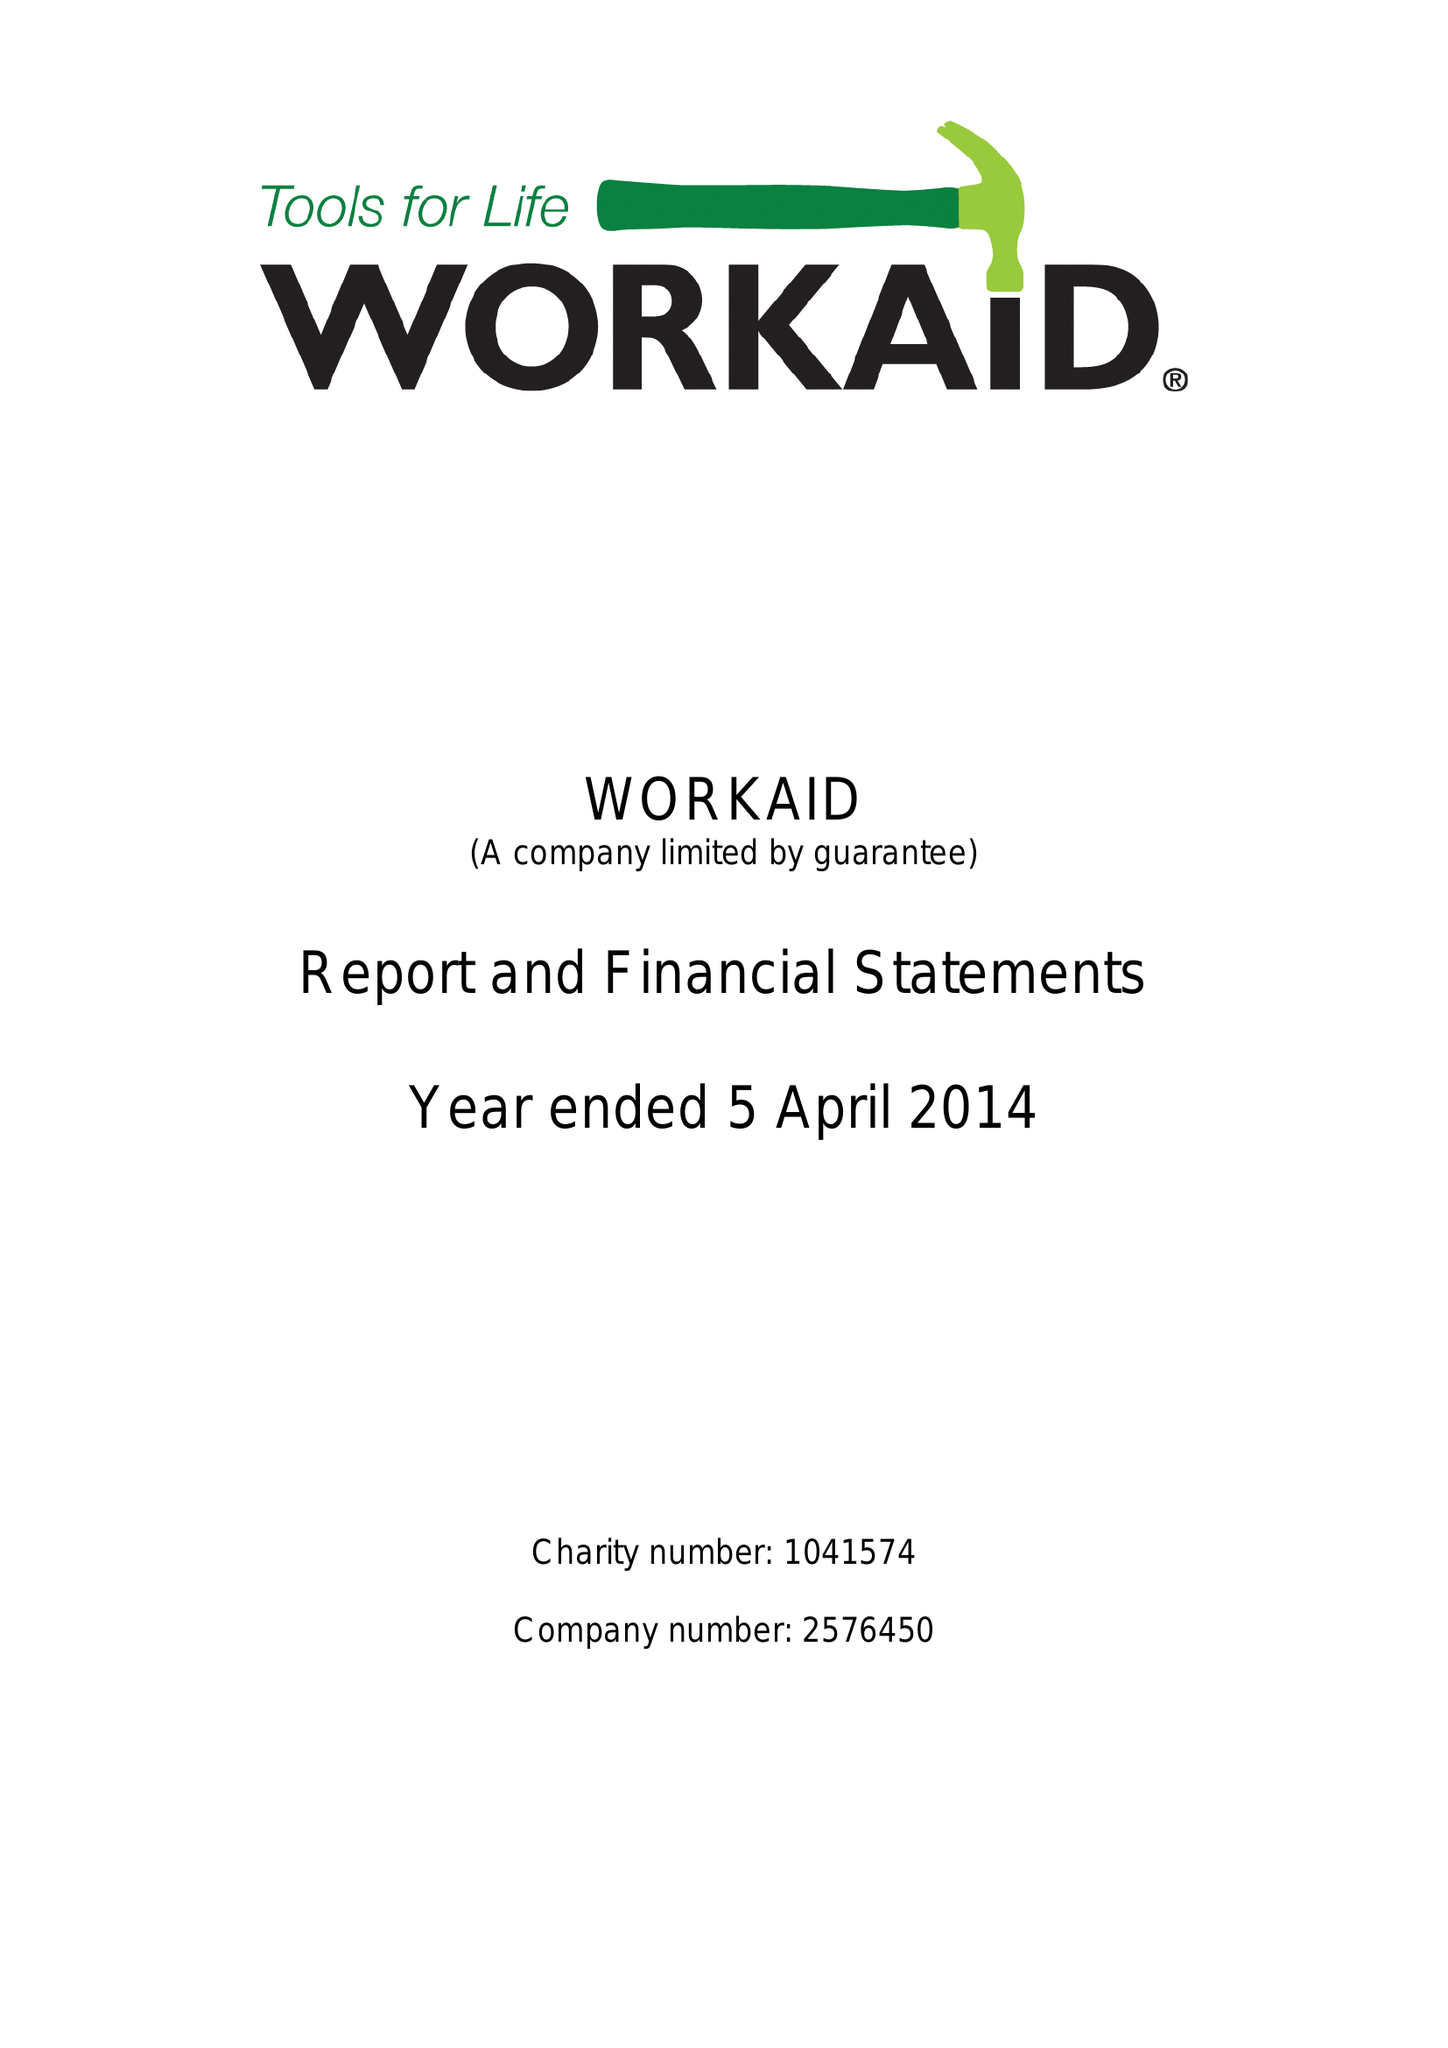What is the value for the report_date?
Answer the question using a single word or phrase. 2014-04-05 